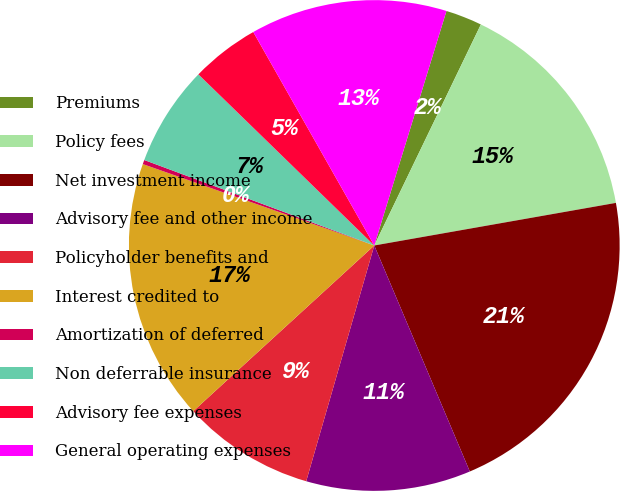Convert chart. <chart><loc_0><loc_0><loc_500><loc_500><pie_chart><fcel>Premiums<fcel>Policy fees<fcel>Net investment income<fcel>Advisory fee and other income<fcel>Policyholder benefits and<fcel>Interest credited to<fcel>Amortization of deferred<fcel>Non deferrable insurance<fcel>Advisory fee expenses<fcel>General operating expenses<nl><fcel>2.4%<fcel>15.07%<fcel>21.41%<fcel>10.84%<fcel>8.73%<fcel>17.18%<fcel>0.28%<fcel>6.62%<fcel>4.51%<fcel>12.96%<nl></chart> 